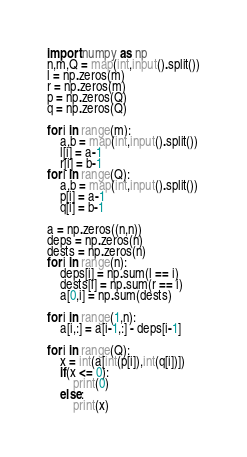Convert code to text. <code><loc_0><loc_0><loc_500><loc_500><_Python_>import numpy as np
n,m,Q = map(int,input().split())
l = np.zeros(m)
r = np.zeros(m)
p = np.zeros(Q)
q = np.zeros(Q)

for i in range(m):
    a,b = map(int,input().split())
    l[i] = a-1
    r[i] = b-1
for i in range(Q):
    a,b = map(int,input().split())
    p[i] = a-1
    q[i] = b-1

a = np.zeros((n,n))
deps = np.zeros(n)
dests = np.zeros(n)
for i in range(n):
    deps[i] = np.sum(l == i)
    dests[i] = np.sum(r == i)
    a[0,i] = np.sum(dests)

for i in range(1,n):
    a[i,:] = a[i-1,:] - deps[i-1]

for i in range(Q):
    x = int(a[int(p[i]),int(q[i])])
    if(x <= 0):
        print(0)
    else:
        print(x)</code> 